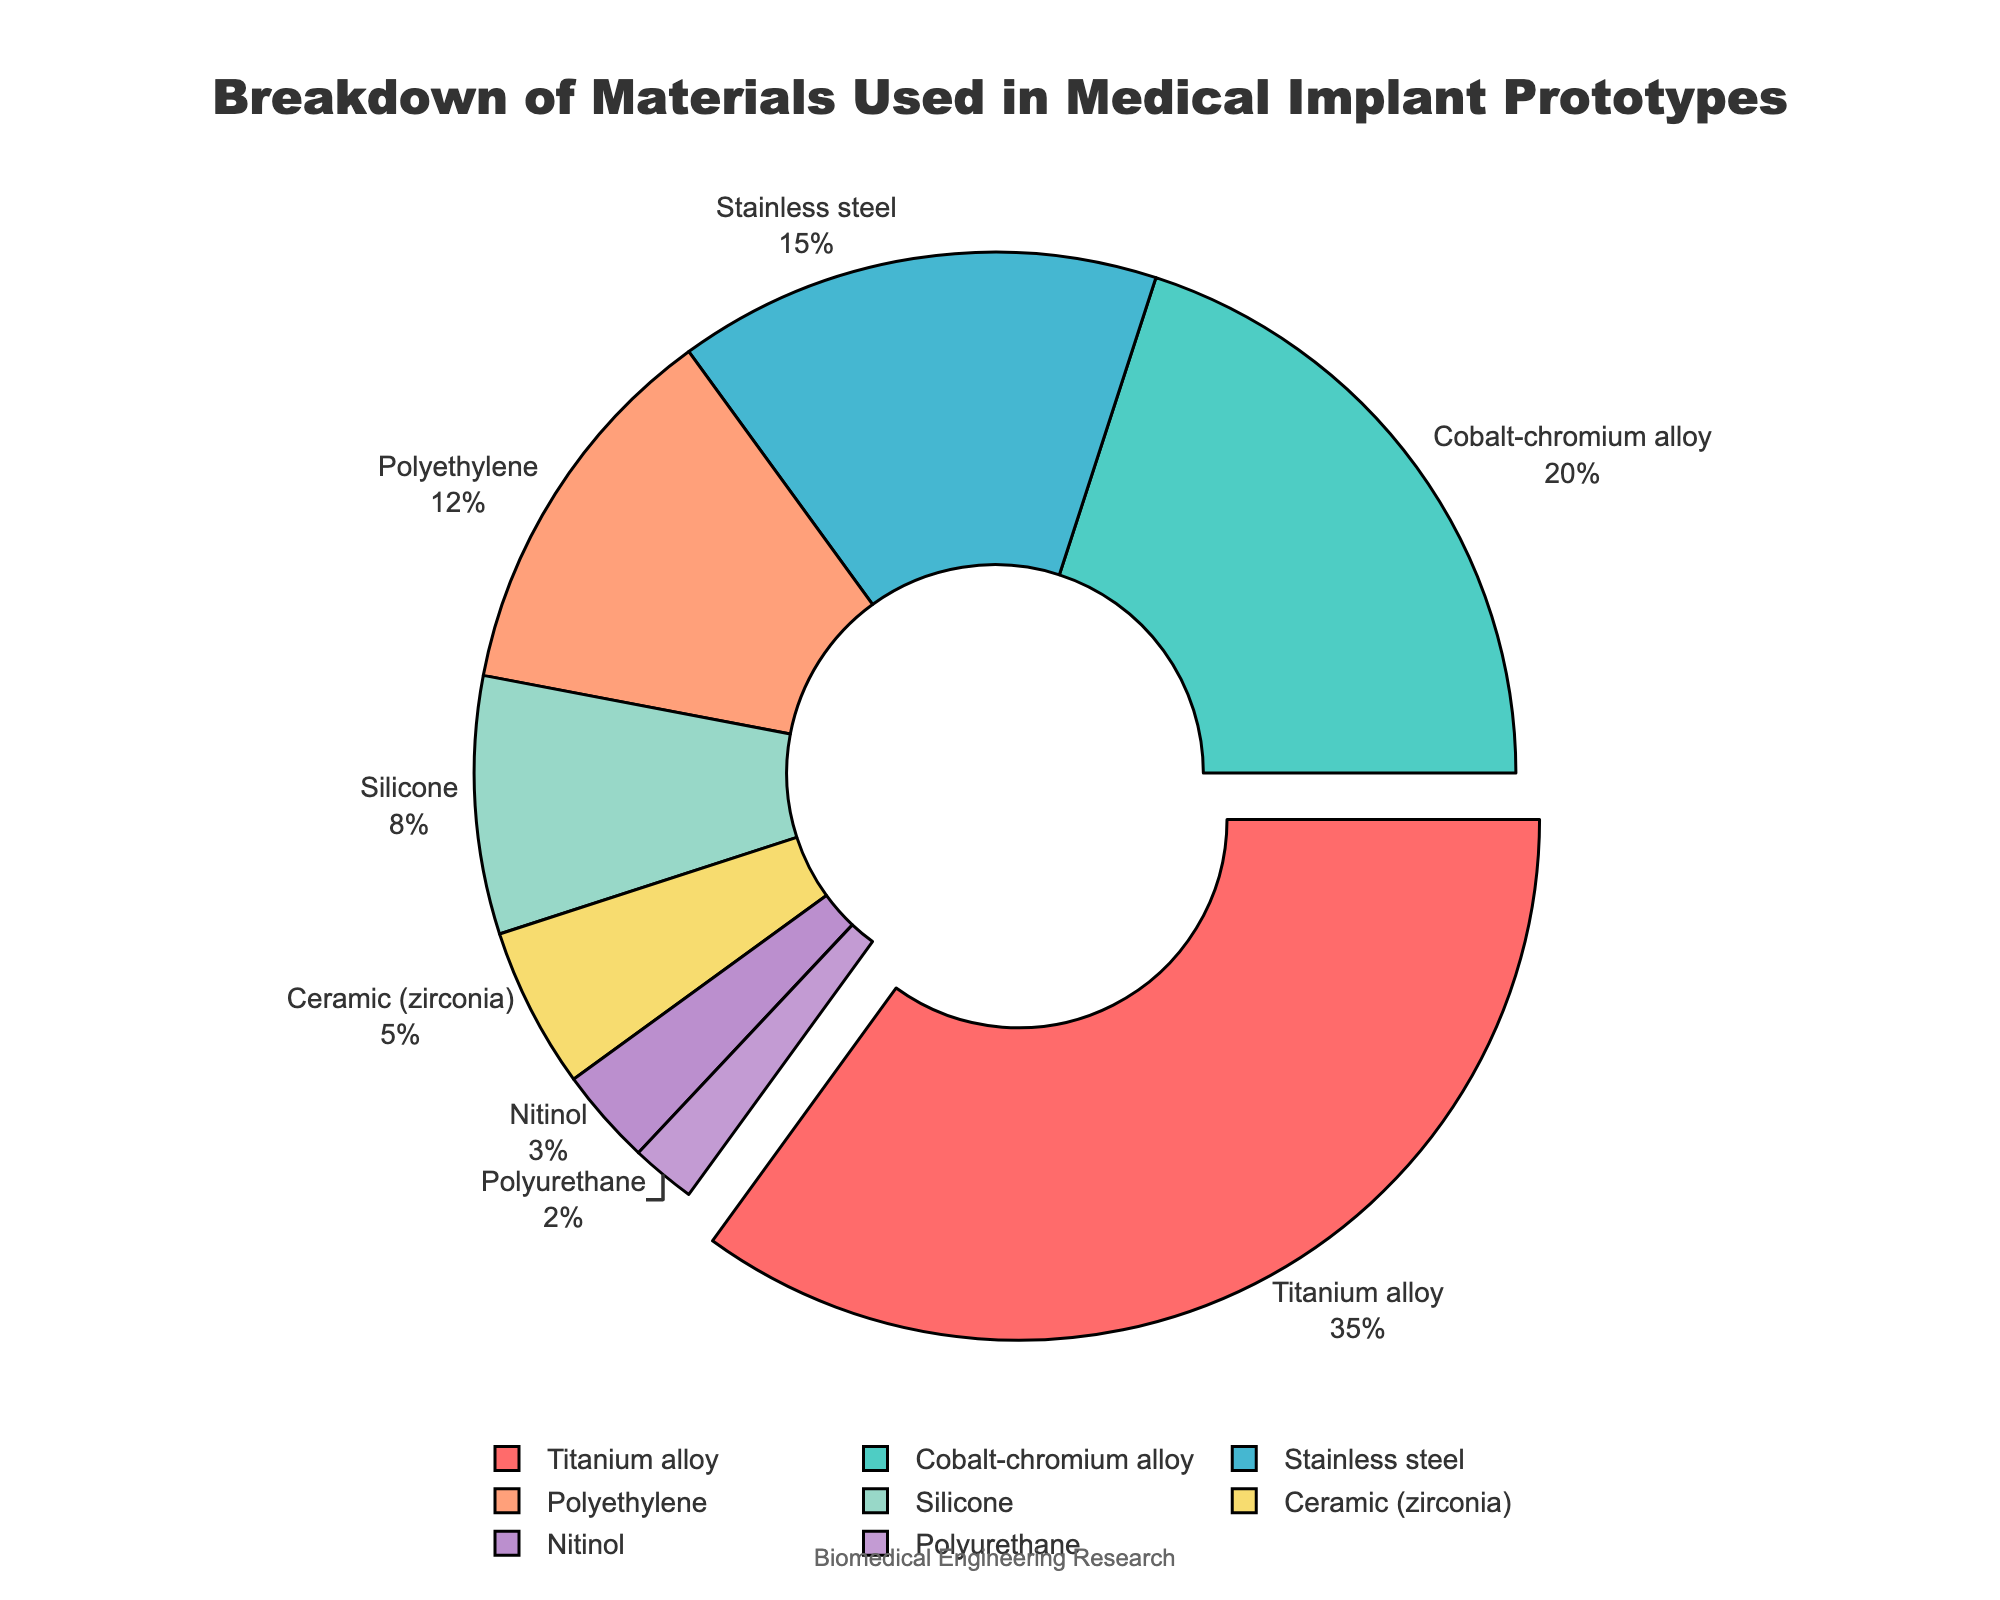What is the most used material in medical implant prototypes? The most used material can be identified as the one with the highest percentage. From the data, Titanium alloy has the highest percentage at 35%.
Answer: Titanium alloy Which two materials together make up more than 50% of the total composition? To find the two materials that together make up more than 50% of the total, we need to sum their percentages and see if it exceeds 50%. Titanium alloy (35%) + Cobalt-chromium alloy (20%) = 55%.
Answer: Titanium alloy and Cobalt-chromium alloy What is the difference in percentage between the material used the most and the material used the least? The material used the most is Titanium alloy with 35%, and the material used the least is Polyurethane with 2%. The difference is calculated as 35% - 2% = 33%.
Answer: 33% What percentage of the materials used are metallic (Titanium alloy, Cobalt-chromium alloy, Stainless steel, and Nitinol)? Sum the percentages of the metallic materials: Titanium alloy (35%) + Cobalt-chromium alloy (20%) + Stainless steel (15%) + Nitinol (3%) = 73%.
Answer: 73% Which material is represented by the red color? By referring to the custom color palette and the order of materials, the red color corresponds to the first material, which is Titanium alloy.
Answer: Titanium alloy Which non-metallic material has the largest percentage? From the given data, the non-metallic materials are Polyethylene, Silicone, Ceramic (zirconia), and Polyurethane. Polyethylene has the highest percentage of 12%.
Answer: Polyethylene How much more popular is Stainless steel compared to Silicone? To determine how much more popular Stainless steel is compared to Silicone, subtract the percentage of Silicone from Stainless steel: 15% - 8% = 7%.
Answer: 7% What is the sum of the percentages for Ceramic (zirconia) and Polyurethane? Add the percentages of Ceramic (zirconia) and Polyurethane: 5% + 2% = 7%.
Answer: 7% What is the visual attribute of the material with the highest percentage? The material with the highest percentage, Titanium alloy, is visually pulled out from the pie chart and highlighted.
Answer: Highlighted and pulled out Which materials together constitute exactly a third of the total percentage? We need two or more materials that add up to approximately 33.33%. Combining Silicone (8%), Ceramic (zirconia) (5%), and Stainless steel (15%), we get 8% + 5% + 15% = 28%, adding Polyethylene (12%) and Nitinol (3%) gives 43%, which is the closest combination. Adjusting the smaller groups, Silicone (8%) + Ceramic (zirconia) (5%) + Polyurethane (2%) gives 15%, add Polyethylene (12%) = 27%, with Nitinol (3%) it sums to 30%. Therefore, combinations need reevaluation with multiple subsets.
Answer: Reeval required combinations for exact 1/3 but closest 27-30% in varied sets 